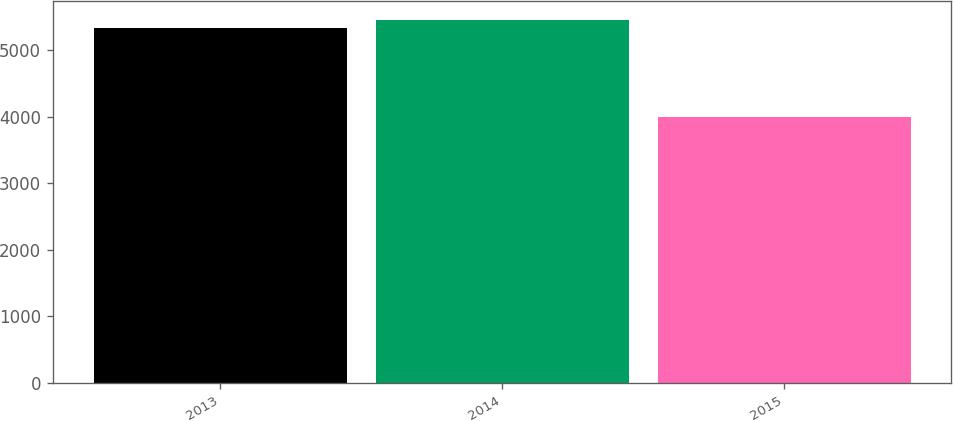Convert chart. <chart><loc_0><loc_0><loc_500><loc_500><bar_chart><fcel>2013<fcel>2014<fcel>2015<nl><fcel>5330<fcel>5463.3<fcel>3997<nl></chart> 